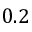Convert formula to latex. <formula><loc_0><loc_0><loc_500><loc_500>0 . 2</formula> 